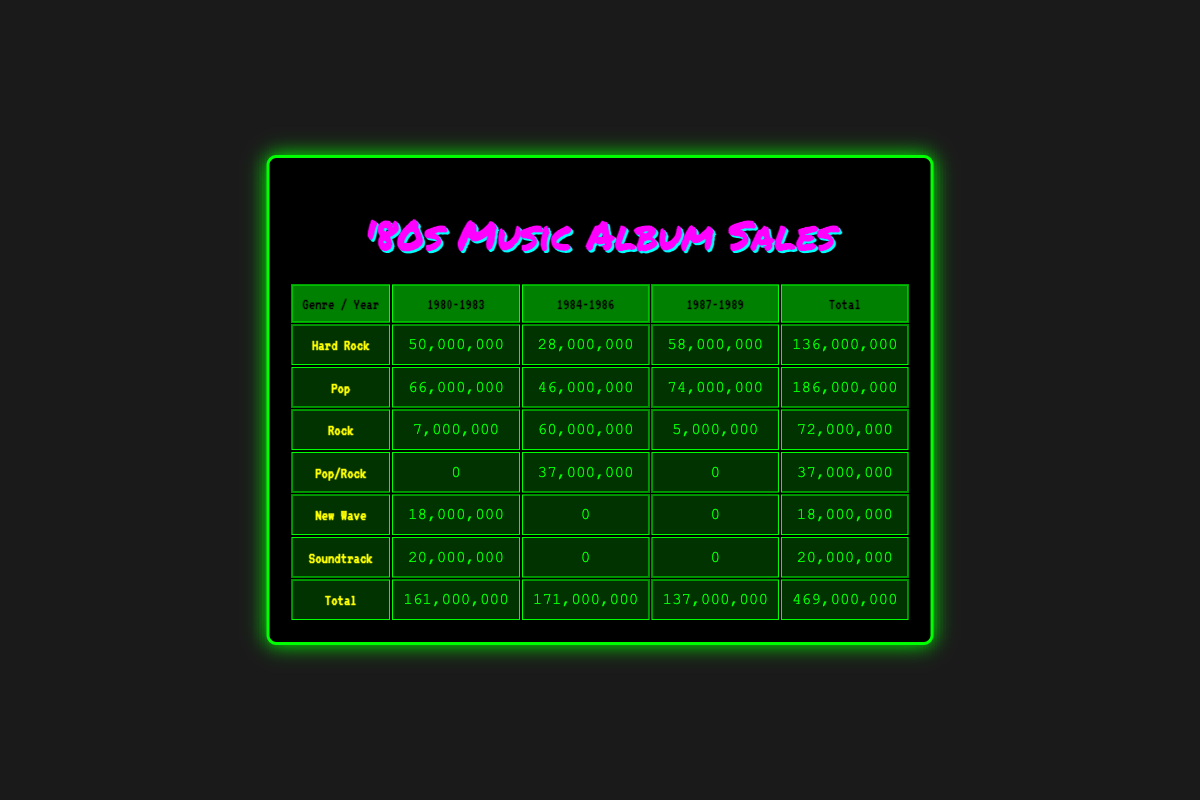What was the total sales for Hard Rock albums from 1980 to 1983? To find this, I look at the row for Hard Rock under the "1980-1983" column, which shows a total of 50,000,000.
Answer: 50,000,000 What is the highest selling album in the Pop genre? By examining the Pop genre row, the total sales is 186,000,000, and the top-selling album is "Thriller" by Michael Jackson with 66,000,000.
Answer: 66,000,000 Did the Rock genre show an increase in sales from 1984 to 1986? The sales for Rock from 1984 to 1986 is 60,000,000, and the previous total in the earlier range is 7,000,000, indicating an increase.
Answer: Yes What are the total sales for the New Wave genre? The New Wave row shows total sales as 18,000,000 across all years.
Answer: 18,000,000 What is the average sales for Pop/Rock genre albums? Since the total sales for Pop/Rock is 37,000,000 and there were 2 albums, the average sales is 37,000,000 divided by 2, which equals 18,500,000.
Answer: 18,500,000 Was there any soundtrack album that sold over 20 million? Checking the Soundtrack row shows total sales as 20,000,000, which does not exceed 20 million.
Answer: No Which genre had the highest sales overall and what was that amount? Looking at the Total row, the highest sales figure is 186,000,000 from the Pop genre, making it the highest overall.
Answer: 186,000,000 How many genres had total sales of over 60 million during the years 1984 to 1986? The Pop and Hard Rock genres had total sales of 46,000,000 and 28,000,000 respectively, only Pop crossed the 60 million mark.
Answer: 1 What was the difference in sales between the highest and lowest genres in 1987 to 1989? The highest was Hard Rock with 58,000,000 sales and the lowest was New Wave at 0, giving a difference of 58,000,000 in sales.
Answer: 58,000,000 